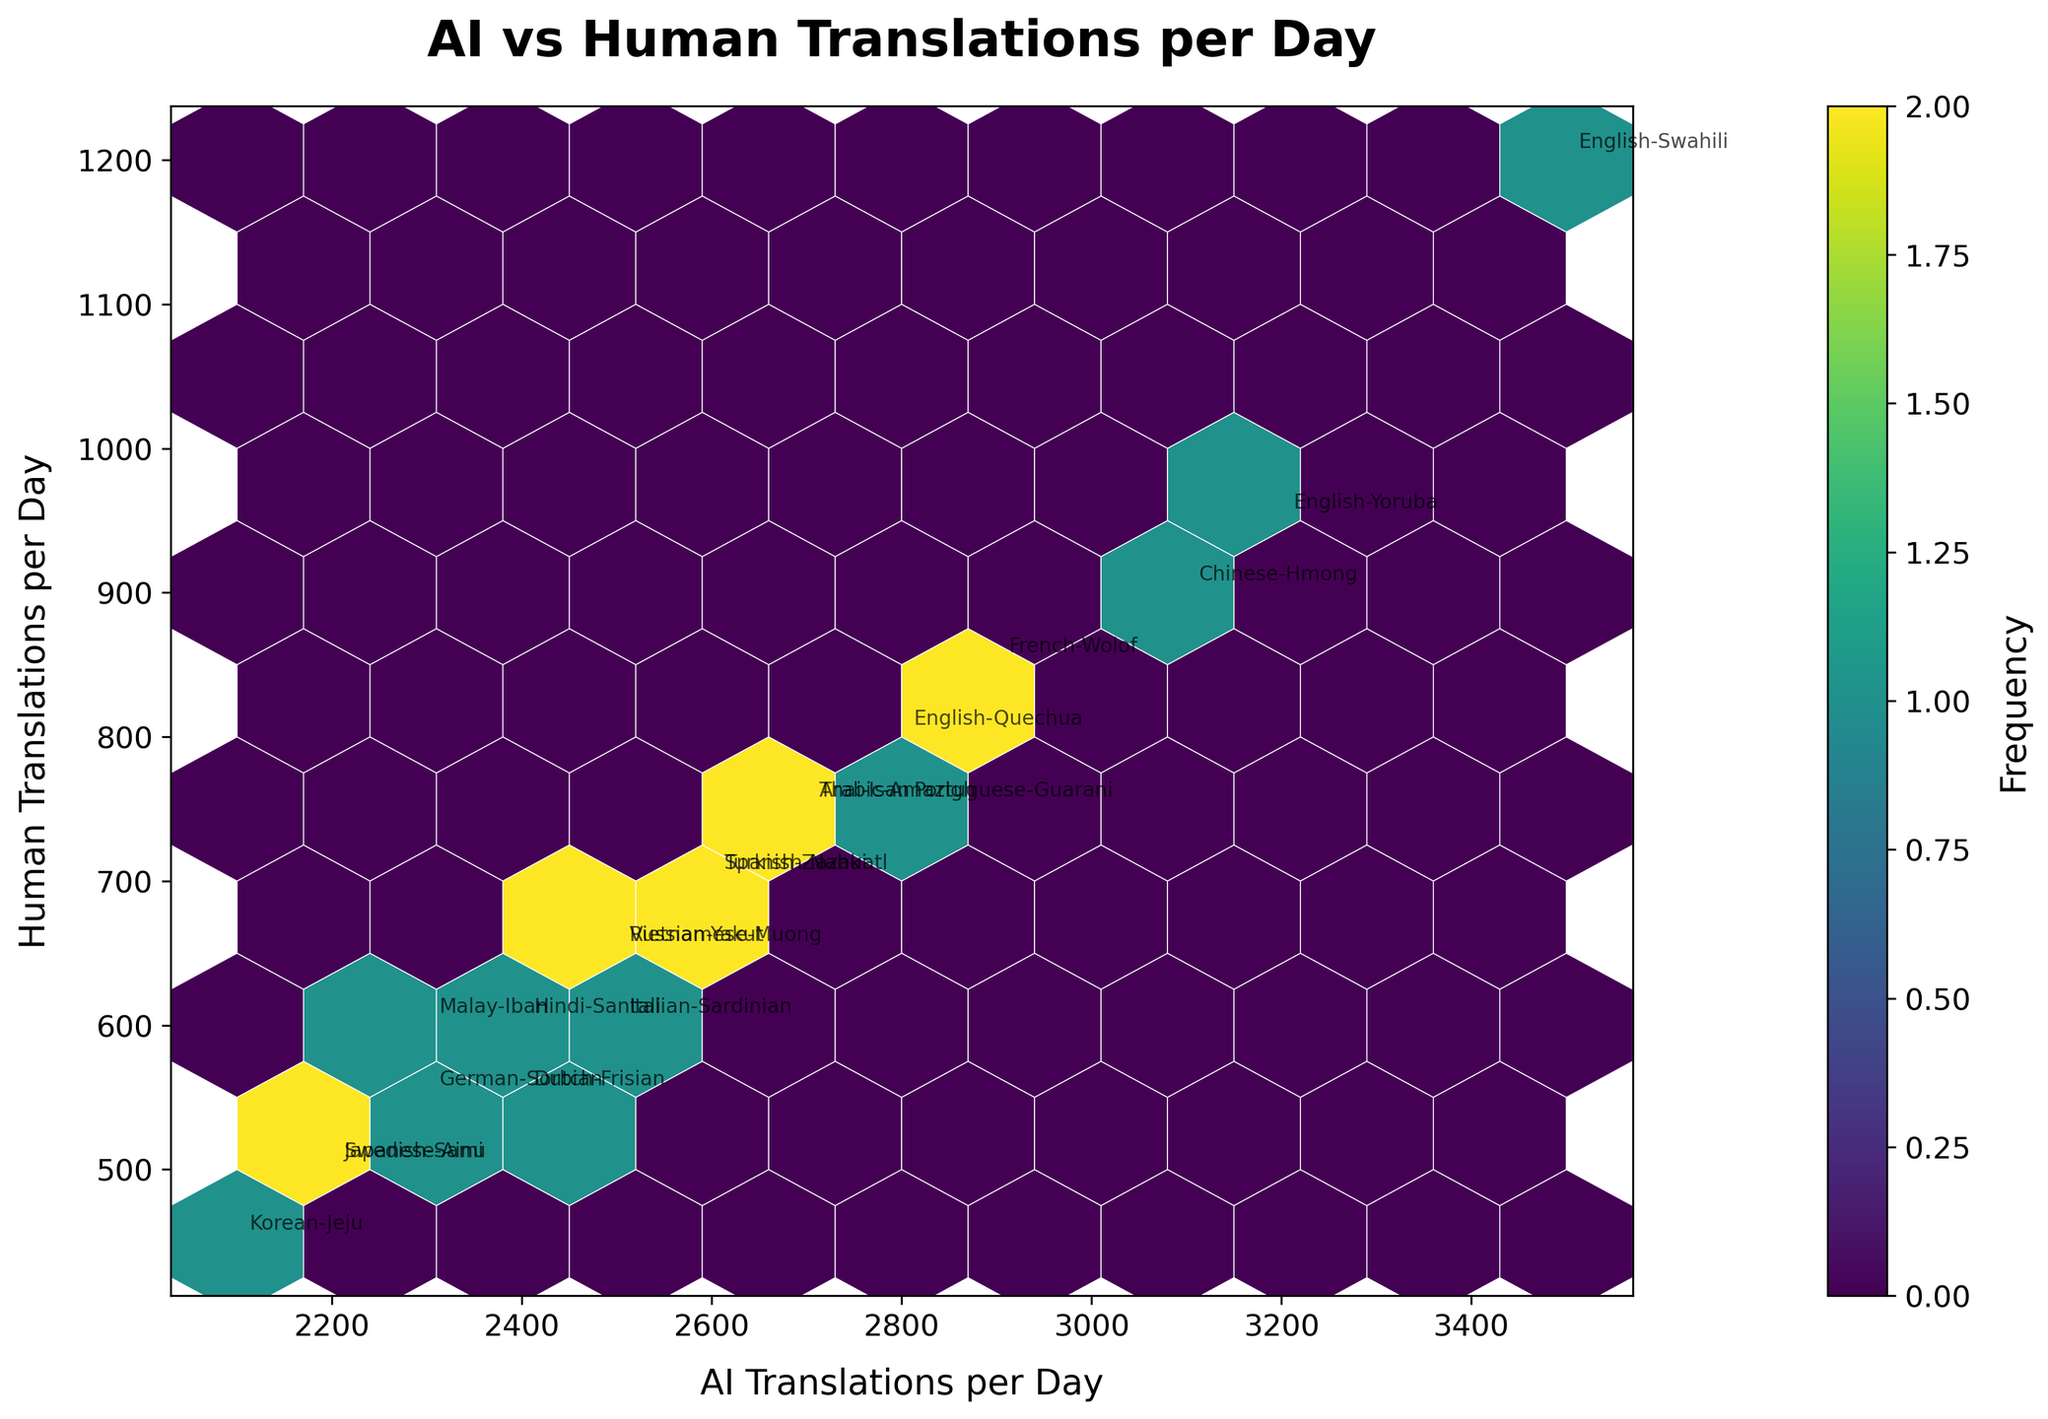How many hexagons are there in the plot? By examining the structure of the hexbin plot, you can see the individual hexagons used to represent the frequency of AI and human translations.
Answer: 10 What languages have AI translations around 3500 per day? Look at the x-axis for values around 3500 and see which data points are labeled with corresponding language pairs.
Answer: English-Swahili Which language pair has the highest human translations per day? Inspect the data points vertically to see which data point reaches the highest value on the y-axis.
Answer: English-Swahili Is there a noticeable clustering of data points? Analyze the concentration of hexagons and the color intensity in certain areas of the plot.
Answer: Yes, there is clustering What is the general trend between AI translations per day and human translations per day? Observe the overall alignment of the data points to understand whether there is a positive trend, a negative trend, or no trend.
Answer: Positive trend How do the translation frequencies of English-Yoruba compare with Japanese-Ainu? Compare the positions of English-Yoruba and Japanese-Ainu on both axes for AI translations and human translations.
Answer: English-Yoruba has higher translations Which language pairs fall into the range of 2000-3000 AI translations and 600-800 human translations? Examine the plot for data points positioned within the specified range on both the x-axis and y-axis.
Answer: English-Quechua, French-Wolof, Portuguese-Guarani, Thai-Isan, Arabic-Amazigh Are there any language pairs with AI translations less than 2200 per day but human translations more than 500 per day? Look for data points below 2200 on the x-axis and above 500 on the y-axis.
Answer: No What does the color intensity in the hexbin plot represent? The color intensity indicates the frequency of data points within each hexagon; darker colors mean higher frequency.
Answer: Frequency Do AI-generated translations or human translations have a wider range of values? Examine the spread of data points along the x-axis and y-axis to see which axis has a wider range.
Answer: AI-generated translations 